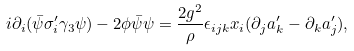Convert formula to latex. <formula><loc_0><loc_0><loc_500><loc_500>i \partial _ { i } ( \bar { \psi } \sigma ^ { \prime } _ { i } \gamma _ { 3 } \psi ) - 2 \phi \bar { \psi } \psi = \frac { 2 g ^ { 2 } } { \rho } \epsilon _ { i j k } x _ { i } ( \partial _ { j } a ^ { \prime } _ { k } - \partial _ { k } a ^ { \prime } _ { j } ) ,</formula> 